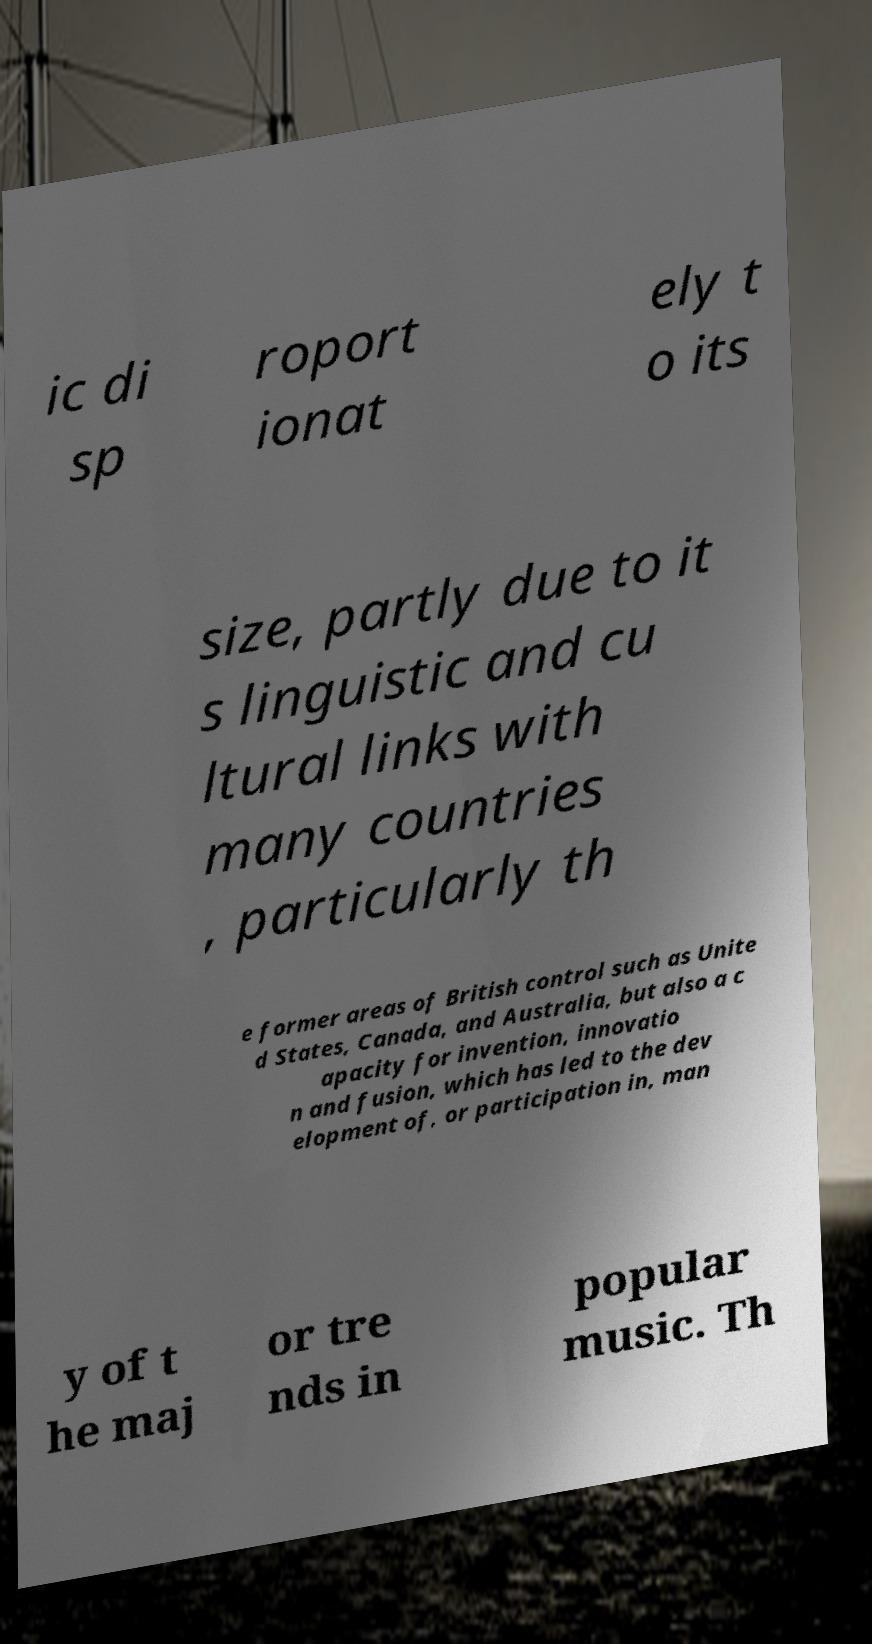Can you read and provide the text displayed in the image?This photo seems to have some interesting text. Can you extract and type it out for me? ic di sp roport ionat ely t o its size, partly due to it s linguistic and cu ltural links with many countries , particularly th e former areas of British control such as Unite d States, Canada, and Australia, but also a c apacity for invention, innovatio n and fusion, which has led to the dev elopment of, or participation in, man y of t he maj or tre nds in popular music. Th 